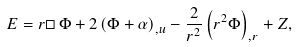Convert formula to latex. <formula><loc_0><loc_0><loc_500><loc_500>E = r \Box \, \Phi + 2 \left ( \Phi + \alpha \right ) _ { , u } - \frac { 2 } { r ^ { 2 } } \left ( r ^ { 2 } \Phi \right ) _ { , r } + Z ,</formula> 